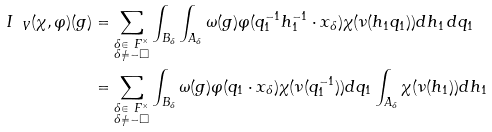<formula> <loc_0><loc_0><loc_500><loc_500>I _ { \ V } ( \chi , \varphi ) ( g ) & = \sum _ { \substack { \delta \in \ F ^ { \times } \\ \delta \neq - \Box } } \int _ { B _ { \delta } } \int _ { A _ { \delta } } \omega ( g ) \varphi ( q _ { 1 } ^ { - 1 } h _ { 1 } ^ { - 1 } \cdot x _ { \delta } ) \chi ( \nu ( h _ { 1 } q _ { 1 } ) ) d h _ { 1 } \, d q _ { 1 } \\ & = \sum _ { \substack { \delta \in \ F ^ { \times } \\ \delta \neq - \Box } } \int _ { B _ { \delta } } \omega ( g ) \varphi ( q _ { 1 } \cdot x _ { \delta } ) \chi ( \nu ( q _ { 1 } ^ { - 1 } ) ) d q _ { 1 } \int _ { A _ { \delta } } \chi ( \nu ( h _ { 1 } ) ) d h _ { 1 }</formula> 